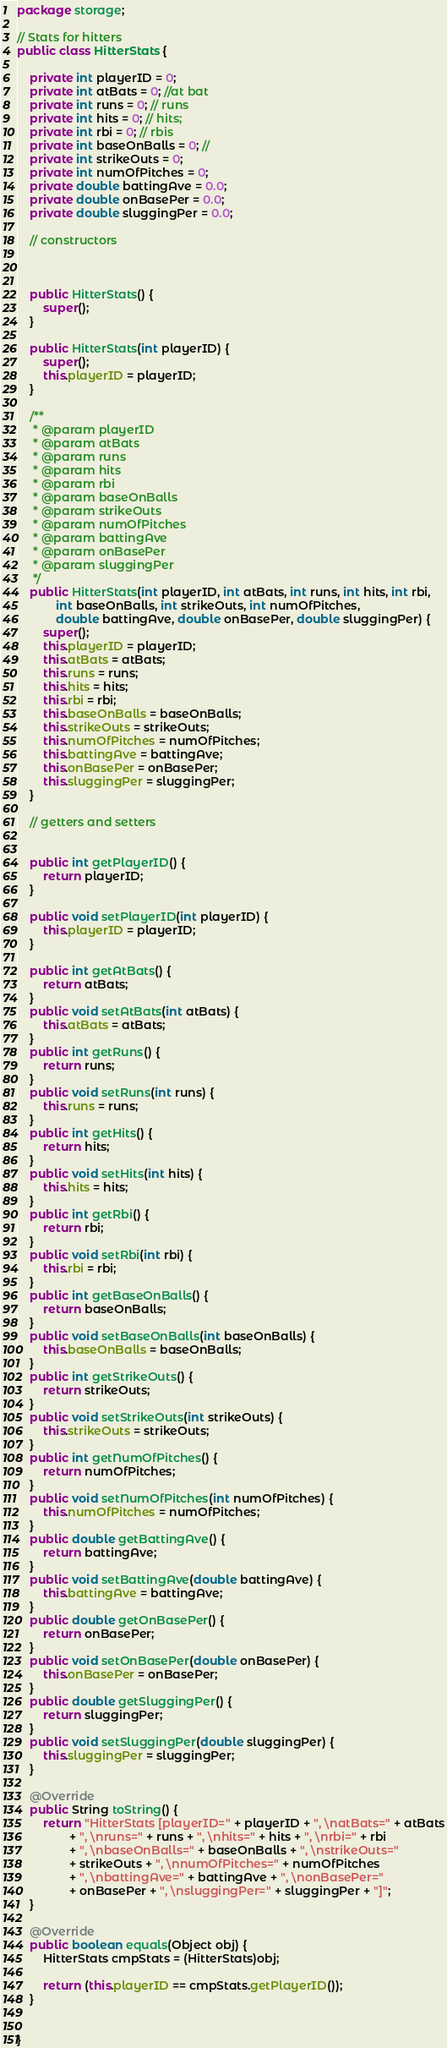Convert code to text. <code><loc_0><loc_0><loc_500><loc_500><_Java_>package storage;

// Stats for hitters 
public class HitterStats {
	
	private int playerID = 0;
	private int atBats = 0; //at bat
	private int runs = 0; // runs
	private int hits = 0; // hits;
	private int rbi = 0; // rbis
	private int baseOnBalls = 0; // 
	private int strikeOuts = 0; 
	private int numOfPitches = 0;
	private double battingAve = 0.0;
	private double onBasePer = 0.0;
	private double sluggingPer = 0.0;
	
	// constructors
	
	
	
	public HitterStats() {
		super();
	}
	
	public HitterStats(int playerID) {
		super();
		this.playerID = playerID;
	}
	
	/**
	 * @param playerID
	 * @param atBats
	 * @param runs
	 * @param hits
	 * @param rbi
	 * @param baseOnBalls
	 * @param strikeOuts
	 * @param numOfPitches
	 * @param battingAve
	 * @param onBasePer
	 * @param sluggingPer
	 */
	public HitterStats(int playerID, int atBats, int runs, int hits, int rbi,
			int baseOnBalls, int strikeOuts, int numOfPitches,
			double battingAve, double onBasePer, double sluggingPer) {
		super();
		this.playerID = playerID;
		this.atBats = atBats;
		this.runs = runs;
		this.hits = hits;
		this.rbi = rbi;
		this.baseOnBalls = baseOnBalls;
		this.strikeOuts = strikeOuts;
		this.numOfPitches = numOfPitches;
		this.battingAve = battingAve;
		this.onBasePer = onBasePer;
		this.sluggingPer = sluggingPer;
	}

	// getters and setters
	

	public int getPlayerID() {
		return playerID;
	}

	public void setPlayerID(int playerID) {
		this.playerID = playerID;
	}

	public int getAtBats() {
		return atBats;
	}
	public void setAtBats(int atBats) {
		this.atBats = atBats;
	}
	public int getRuns() {
		return runs;
	}
	public void setRuns(int runs) {
		this.runs = runs;
	}
	public int getHits() {
		return hits;
	}
	public void setHits(int hits) {
		this.hits = hits;
	}
	public int getRbi() {
		return rbi;
	}
	public void setRbi(int rbi) {
		this.rbi = rbi;
	}
	public int getBaseOnBalls() {
		return baseOnBalls;
	}
	public void setBaseOnBalls(int baseOnBalls) {
		this.baseOnBalls = baseOnBalls;
	}
	public int getStrikeOuts() {
		return strikeOuts;
	}
	public void setStrikeOuts(int strikeOuts) {
		this.strikeOuts = strikeOuts;
	}
	public int getNumOfPitches() {
		return numOfPitches;
	}
	public void setNumOfPitches(int numOfPitches) {
		this.numOfPitches = numOfPitches;
	}
	public double getBattingAve() {
		return battingAve;
	}
	public void setBattingAve(double battingAve) {
		this.battingAve = battingAve;
	}
	public double getOnBasePer() {
		return onBasePer;
	}
	public void setOnBasePer(double onBasePer) {
		this.onBasePer = onBasePer;
	}
	public double getSluggingPer() {
		return sluggingPer;
	}
	public void setSluggingPer(double sluggingPer) {
		this.sluggingPer = sluggingPer;
	}

	@Override
	public String toString() {
		return "HitterStats [playerID=" + playerID + ", \natBats=" + atBats
				+ ", \nruns=" + runs + ", \nhits=" + hits + ", \nrbi=" + rbi
				+ ", \nbaseOnBalls=" + baseOnBalls + ", \nstrikeOuts="
				+ strikeOuts + ", \nnumOfPitches=" + numOfPitches
				+ ", \nbattingAve=" + battingAve + ", \nonBasePer="
				+ onBasePer + ", \nsluggingPer=" + sluggingPer + "]";
	}

	@Override
	public boolean equals(Object obj) {
		HitterStats cmpStats = (HitterStats)obj;
		
		return (this.playerID == cmpStats.getPlayerID());
	}
	
	
}
</code> 